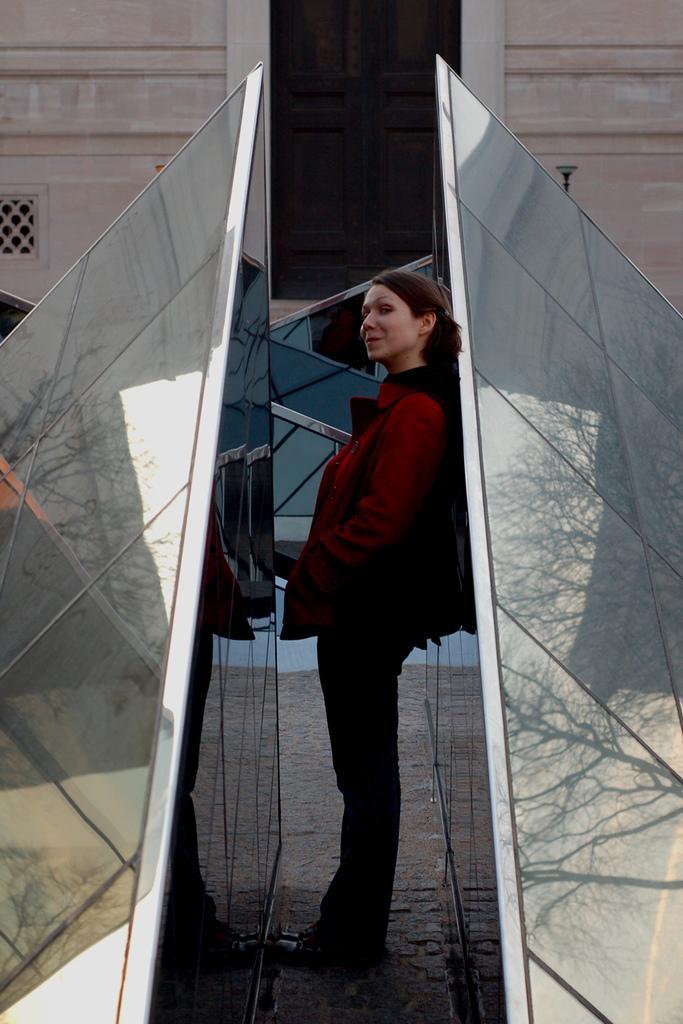Please provide a concise description of this image. In this picture there is a woman standing. On the left and on the right side of the image there are mirrors. There is a reflection of sky and tree and building on the mirrors. At the back there is a building. 